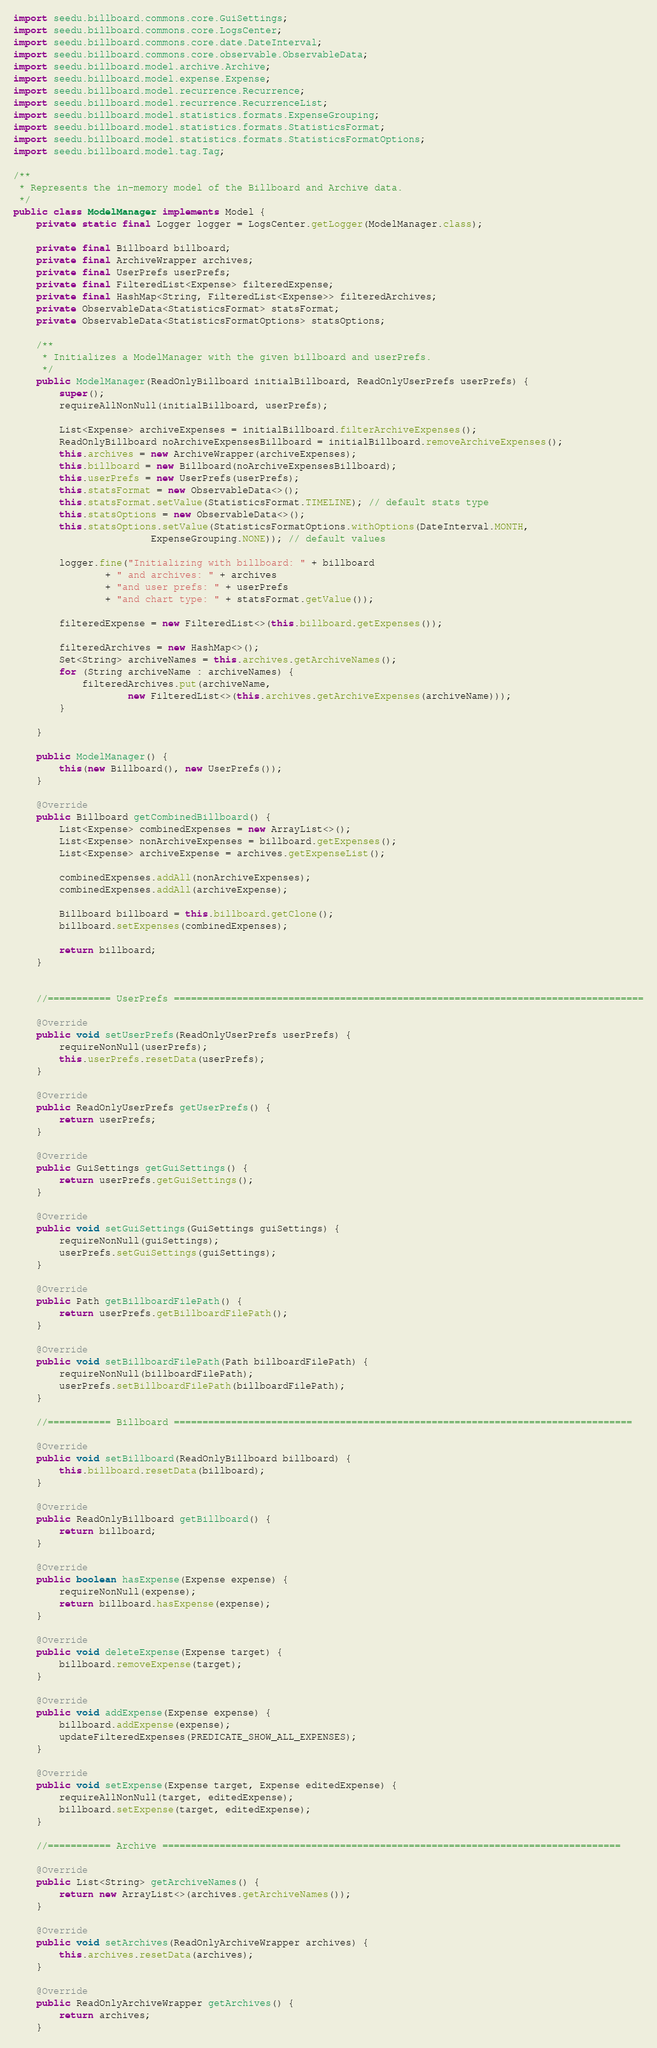Convert code to text. <code><loc_0><loc_0><loc_500><loc_500><_Java_>import seedu.billboard.commons.core.GuiSettings;
import seedu.billboard.commons.core.LogsCenter;
import seedu.billboard.commons.core.date.DateInterval;
import seedu.billboard.commons.core.observable.ObservableData;
import seedu.billboard.model.archive.Archive;
import seedu.billboard.model.expense.Expense;
import seedu.billboard.model.recurrence.Recurrence;
import seedu.billboard.model.recurrence.RecurrenceList;
import seedu.billboard.model.statistics.formats.ExpenseGrouping;
import seedu.billboard.model.statistics.formats.StatisticsFormat;
import seedu.billboard.model.statistics.formats.StatisticsFormatOptions;
import seedu.billboard.model.tag.Tag;

/**
 * Represents the in-memory model of the Billboard and Archive data.
 */
public class ModelManager implements Model {
    private static final Logger logger = LogsCenter.getLogger(ModelManager.class);

    private final Billboard billboard;
    private final ArchiveWrapper archives;
    private final UserPrefs userPrefs;
    private final FilteredList<Expense> filteredExpense;
    private final HashMap<String, FilteredList<Expense>> filteredArchives;
    private ObservableData<StatisticsFormat> statsFormat;
    private ObservableData<StatisticsFormatOptions> statsOptions;

    /**
     * Initializes a ModelManager with the given billboard and userPrefs.
     */
    public ModelManager(ReadOnlyBillboard initialBillboard, ReadOnlyUserPrefs userPrefs) {
        super();
        requireAllNonNull(initialBillboard, userPrefs);

        List<Expense> archiveExpenses = initialBillboard.filterArchiveExpenses();
        ReadOnlyBillboard noArchiveExpensesBillboard = initialBillboard.removeArchiveExpenses();
        this.archives = new ArchiveWrapper(archiveExpenses);
        this.billboard = new Billboard(noArchiveExpensesBillboard);
        this.userPrefs = new UserPrefs(userPrefs);
        this.statsFormat = new ObservableData<>();
        this.statsFormat.setValue(StatisticsFormat.TIMELINE); // default stats type
        this.statsOptions = new ObservableData<>();
        this.statsOptions.setValue(StatisticsFormatOptions.withOptions(DateInterval.MONTH,
                        ExpenseGrouping.NONE)); // default values

        logger.fine("Initializing with billboard: " + billboard
                + " and archives: " + archives
                + "and user prefs: " + userPrefs
                + "and chart type: " + statsFormat.getValue());

        filteredExpense = new FilteredList<>(this.billboard.getExpenses());

        filteredArchives = new HashMap<>();
        Set<String> archiveNames = this.archives.getArchiveNames();
        for (String archiveName : archiveNames) {
            filteredArchives.put(archiveName,
                    new FilteredList<>(this.archives.getArchiveExpenses(archiveName)));
        }

    }

    public ModelManager() {
        this(new Billboard(), new UserPrefs());
    }

    @Override
    public Billboard getCombinedBillboard() {
        List<Expense> combinedExpenses = new ArrayList<>();
        List<Expense> nonArchiveExpenses = billboard.getExpenses();
        List<Expense> archiveExpense = archives.getExpenseList();

        combinedExpenses.addAll(nonArchiveExpenses);
        combinedExpenses.addAll(archiveExpense);

        Billboard billboard = this.billboard.getClone();
        billboard.setExpenses(combinedExpenses);

        return billboard;
    }


    //=========== UserPrefs ==================================================================================

    @Override
    public void setUserPrefs(ReadOnlyUserPrefs userPrefs) {
        requireNonNull(userPrefs);
        this.userPrefs.resetData(userPrefs);
    }

    @Override
    public ReadOnlyUserPrefs getUserPrefs() {
        return userPrefs;
    }

    @Override
    public GuiSettings getGuiSettings() {
        return userPrefs.getGuiSettings();
    }

    @Override
    public void setGuiSettings(GuiSettings guiSettings) {
        requireNonNull(guiSettings);
        userPrefs.setGuiSettings(guiSettings);
    }

    @Override
    public Path getBillboardFilePath() {
        return userPrefs.getBillboardFilePath();
    }

    @Override
    public void setBillboardFilePath(Path billboardFilePath) {
        requireNonNull(billboardFilePath);
        userPrefs.setBillboardFilePath(billboardFilePath);
    }

    //=========== Billboard ================================================================================

    @Override
    public void setBillboard(ReadOnlyBillboard billboard) {
        this.billboard.resetData(billboard);
    }

    @Override
    public ReadOnlyBillboard getBillboard() {
        return billboard;
    }

    @Override
    public boolean hasExpense(Expense expense) {
        requireNonNull(expense);
        return billboard.hasExpense(expense);
    }

    @Override
    public void deleteExpense(Expense target) {
        billboard.removeExpense(target);
    }

    @Override
    public void addExpense(Expense expense) {
        billboard.addExpense(expense);
        updateFilteredExpenses(PREDICATE_SHOW_ALL_EXPENSES);
    }

    @Override
    public void setExpense(Expense target, Expense editedExpense) {
        requireAllNonNull(target, editedExpense);
        billboard.setExpense(target, editedExpense);
    }

    //=========== Archive ================================================================================

    @Override
    public List<String> getArchiveNames() {
        return new ArrayList<>(archives.getArchiveNames());
    }

    @Override
    public void setArchives(ReadOnlyArchiveWrapper archives) {
        this.archives.resetData(archives);
    }

    @Override
    public ReadOnlyArchiveWrapper getArchives() {
        return archives;
    }
</code> 